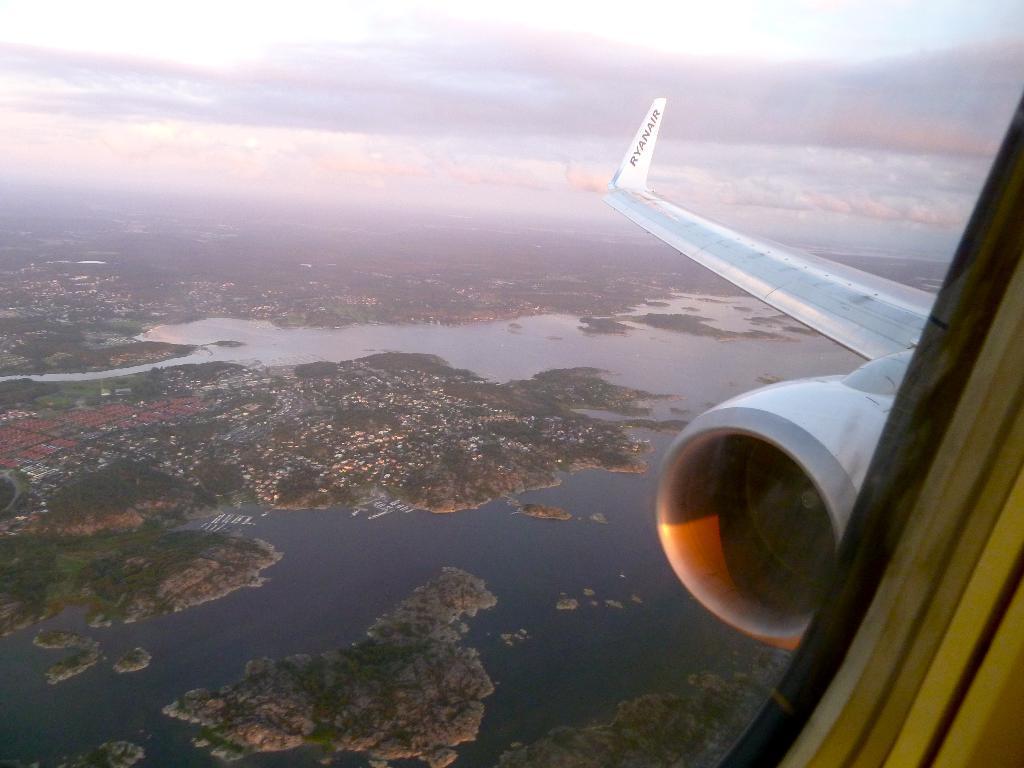In one or two sentences, can you explain what this image depicts? In this image we can see a wing and engine of an airplane, beneath the airplane on the surface there are trees and water. 